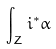Convert formula to latex. <formula><loc_0><loc_0><loc_500><loc_500>\int _ { Z } i ^ { * } \alpha</formula> 